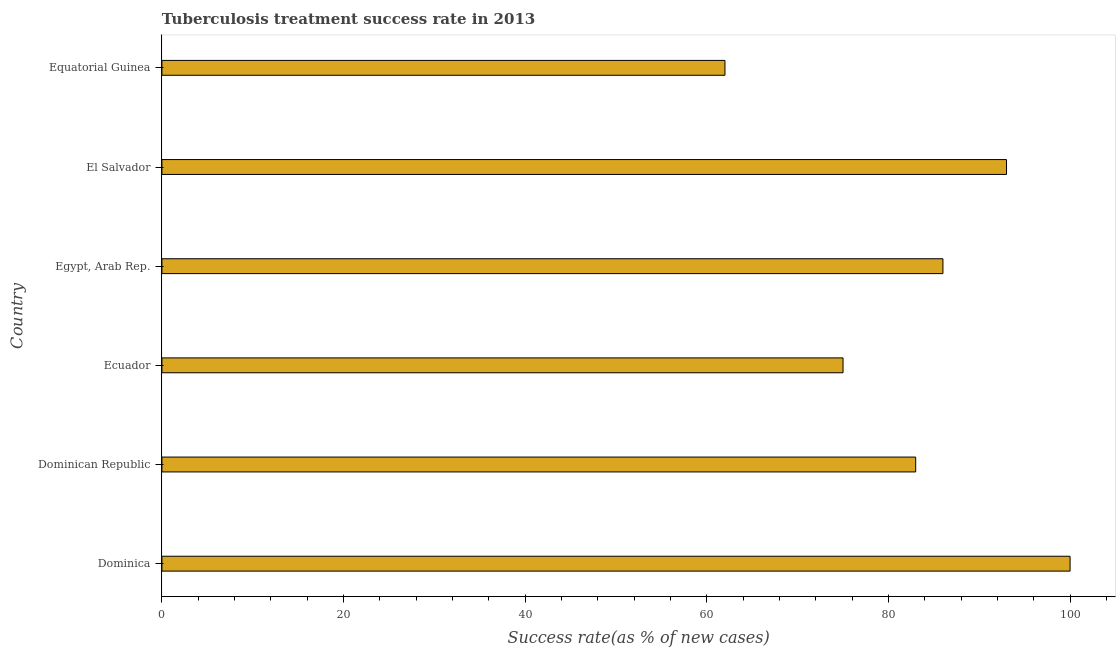What is the title of the graph?
Provide a succinct answer. Tuberculosis treatment success rate in 2013. What is the label or title of the X-axis?
Keep it short and to the point. Success rate(as % of new cases). What is the tuberculosis treatment success rate in El Salvador?
Offer a terse response. 93. In which country was the tuberculosis treatment success rate maximum?
Your answer should be very brief. Dominica. In which country was the tuberculosis treatment success rate minimum?
Provide a succinct answer. Equatorial Guinea. What is the sum of the tuberculosis treatment success rate?
Your response must be concise. 499. What is the average tuberculosis treatment success rate per country?
Your answer should be very brief. 83. What is the median tuberculosis treatment success rate?
Your answer should be compact. 84.5. In how many countries, is the tuberculosis treatment success rate greater than 40 %?
Your answer should be very brief. 6. What is the ratio of the tuberculosis treatment success rate in Dominica to that in Dominican Republic?
Your answer should be very brief. 1.21. Is the difference between the tuberculosis treatment success rate in Dominica and Equatorial Guinea greater than the difference between any two countries?
Your response must be concise. Yes. In how many countries, is the tuberculosis treatment success rate greater than the average tuberculosis treatment success rate taken over all countries?
Your response must be concise. 3. Are all the bars in the graph horizontal?
Your response must be concise. Yes. How many countries are there in the graph?
Your answer should be compact. 6. Are the values on the major ticks of X-axis written in scientific E-notation?
Your response must be concise. No. What is the Success rate(as % of new cases) of Dominica?
Offer a terse response. 100. What is the Success rate(as % of new cases) in Dominican Republic?
Offer a terse response. 83. What is the Success rate(as % of new cases) in Egypt, Arab Rep.?
Give a very brief answer. 86. What is the Success rate(as % of new cases) in El Salvador?
Provide a succinct answer. 93. What is the difference between the Success rate(as % of new cases) in Dominica and Dominican Republic?
Your answer should be compact. 17. What is the difference between the Success rate(as % of new cases) in Dominica and Egypt, Arab Rep.?
Your answer should be compact. 14. What is the difference between the Success rate(as % of new cases) in Dominica and Equatorial Guinea?
Ensure brevity in your answer.  38. What is the difference between the Success rate(as % of new cases) in Dominican Republic and Ecuador?
Provide a short and direct response. 8. What is the difference between the Success rate(as % of new cases) in Dominican Republic and Egypt, Arab Rep.?
Your response must be concise. -3. What is the difference between the Success rate(as % of new cases) in Dominican Republic and Equatorial Guinea?
Provide a short and direct response. 21. What is the difference between the Success rate(as % of new cases) in Ecuador and Egypt, Arab Rep.?
Your response must be concise. -11. What is the difference between the Success rate(as % of new cases) in Ecuador and Equatorial Guinea?
Give a very brief answer. 13. What is the difference between the Success rate(as % of new cases) in Egypt, Arab Rep. and El Salvador?
Ensure brevity in your answer.  -7. What is the difference between the Success rate(as % of new cases) in Egypt, Arab Rep. and Equatorial Guinea?
Provide a short and direct response. 24. What is the difference between the Success rate(as % of new cases) in El Salvador and Equatorial Guinea?
Provide a short and direct response. 31. What is the ratio of the Success rate(as % of new cases) in Dominica to that in Dominican Republic?
Keep it short and to the point. 1.21. What is the ratio of the Success rate(as % of new cases) in Dominica to that in Ecuador?
Give a very brief answer. 1.33. What is the ratio of the Success rate(as % of new cases) in Dominica to that in Egypt, Arab Rep.?
Keep it short and to the point. 1.16. What is the ratio of the Success rate(as % of new cases) in Dominica to that in El Salvador?
Your response must be concise. 1.07. What is the ratio of the Success rate(as % of new cases) in Dominica to that in Equatorial Guinea?
Offer a terse response. 1.61. What is the ratio of the Success rate(as % of new cases) in Dominican Republic to that in Ecuador?
Your response must be concise. 1.11. What is the ratio of the Success rate(as % of new cases) in Dominican Republic to that in Egypt, Arab Rep.?
Make the answer very short. 0.96. What is the ratio of the Success rate(as % of new cases) in Dominican Republic to that in El Salvador?
Ensure brevity in your answer.  0.89. What is the ratio of the Success rate(as % of new cases) in Dominican Republic to that in Equatorial Guinea?
Your answer should be compact. 1.34. What is the ratio of the Success rate(as % of new cases) in Ecuador to that in Egypt, Arab Rep.?
Offer a very short reply. 0.87. What is the ratio of the Success rate(as % of new cases) in Ecuador to that in El Salvador?
Offer a very short reply. 0.81. What is the ratio of the Success rate(as % of new cases) in Ecuador to that in Equatorial Guinea?
Provide a succinct answer. 1.21. What is the ratio of the Success rate(as % of new cases) in Egypt, Arab Rep. to that in El Salvador?
Your response must be concise. 0.93. What is the ratio of the Success rate(as % of new cases) in Egypt, Arab Rep. to that in Equatorial Guinea?
Your answer should be compact. 1.39. 